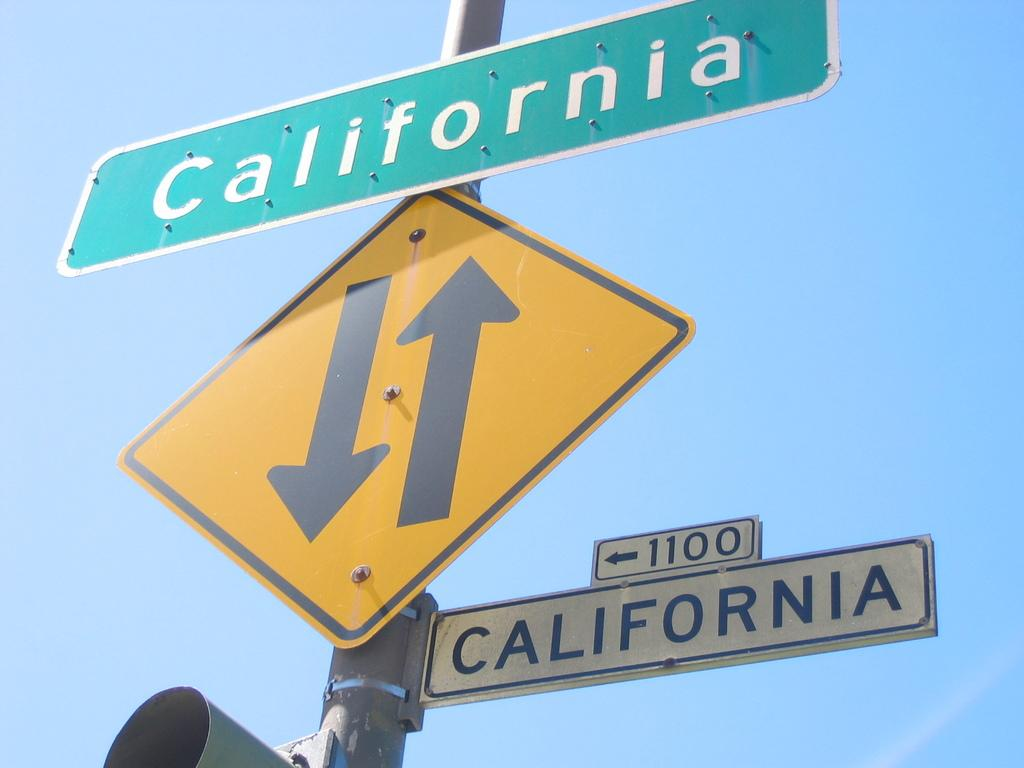<image>
Describe the image concisely. A yellow traffic sign is on a pole with two other signs that state California. 